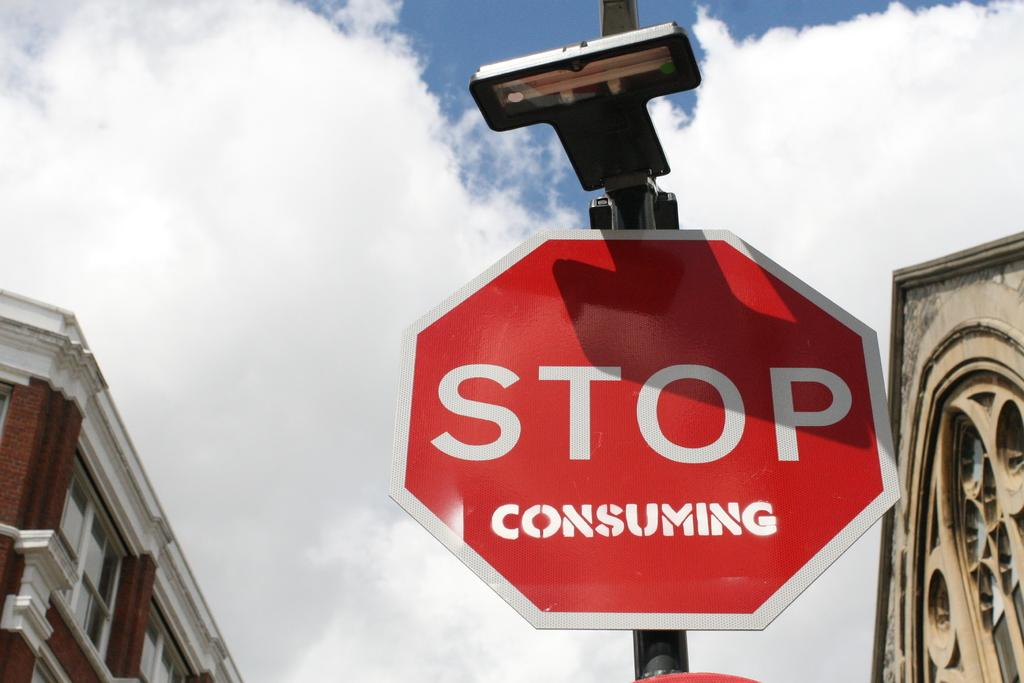<image>
Create a compact narrative representing the image presented. Someone has written consuming on a stop sign. 